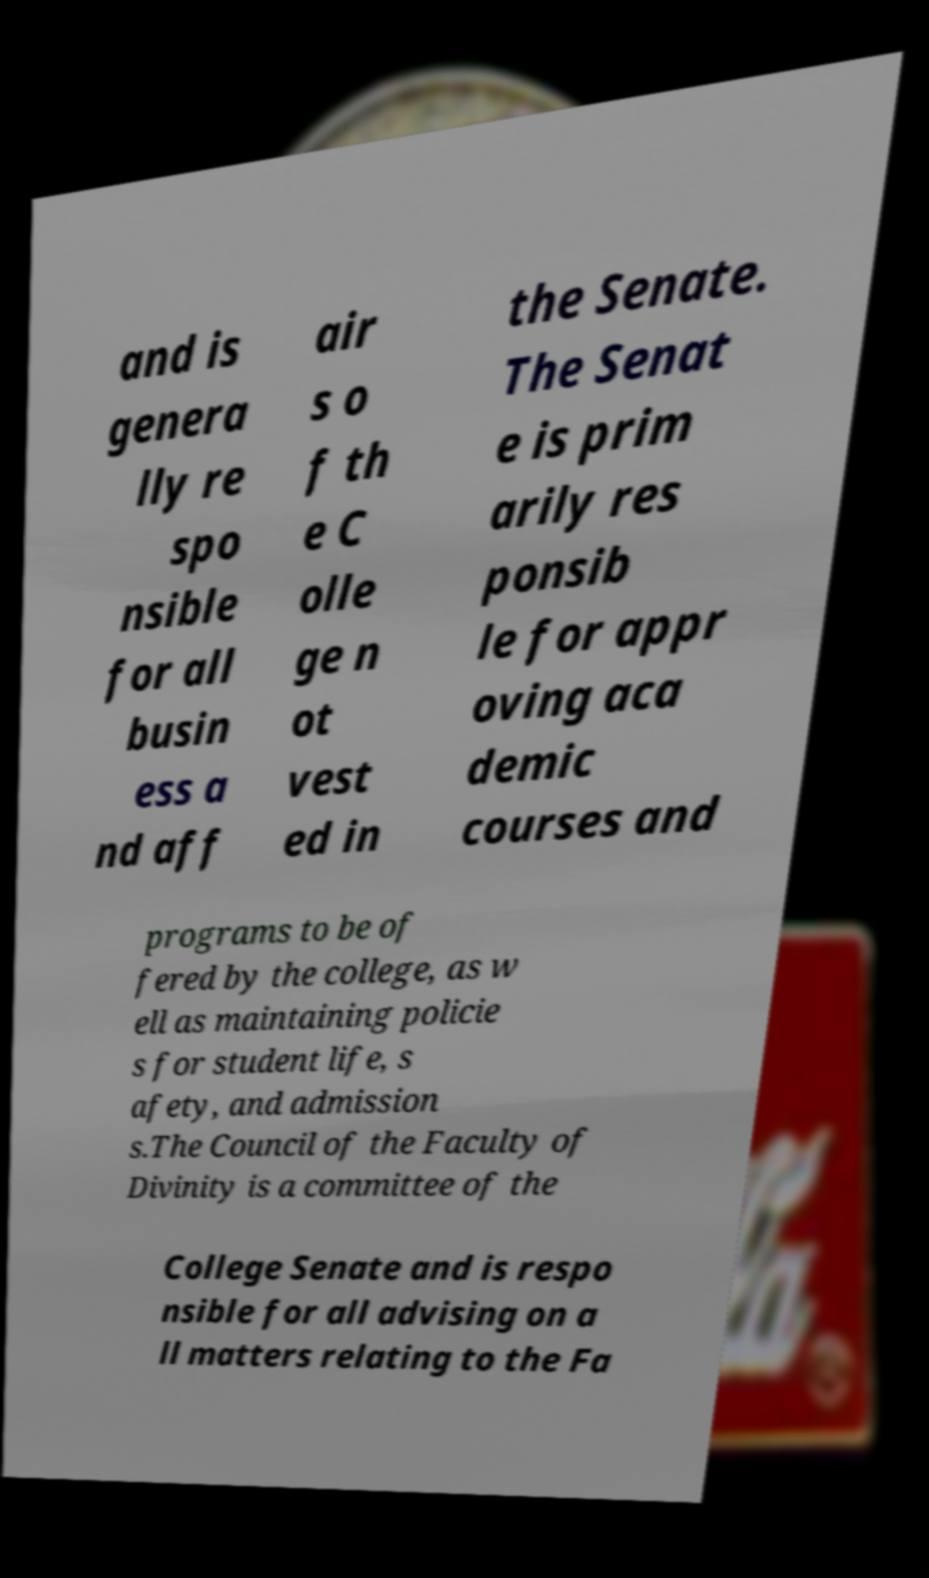Please identify and transcribe the text found in this image. and is genera lly re spo nsible for all busin ess a nd aff air s o f th e C olle ge n ot vest ed in the Senate. The Senat e is prim arily res ponsib le for appr oving aca demic courses and programs to be of fered by the college, as w ell as maintaining policie s for student life, s afety, and admission s.The Council of the Faculty of Divinity is a committee of the College Senate and is respo nsible for all advising on a ll matters relating to the Fa 